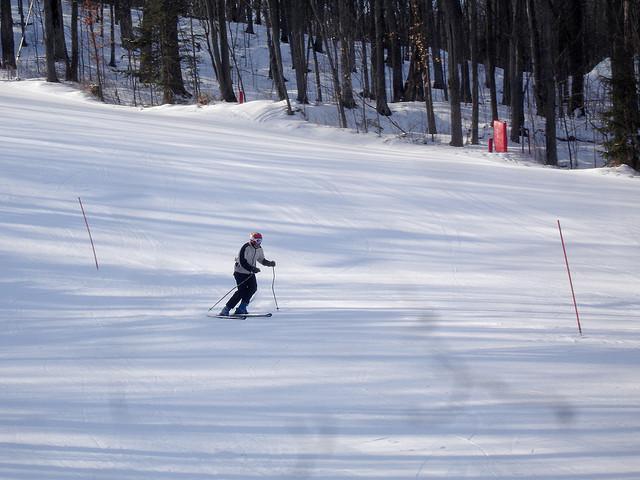How many planes have orange tail sections?
Give a very brief answer. 0. 